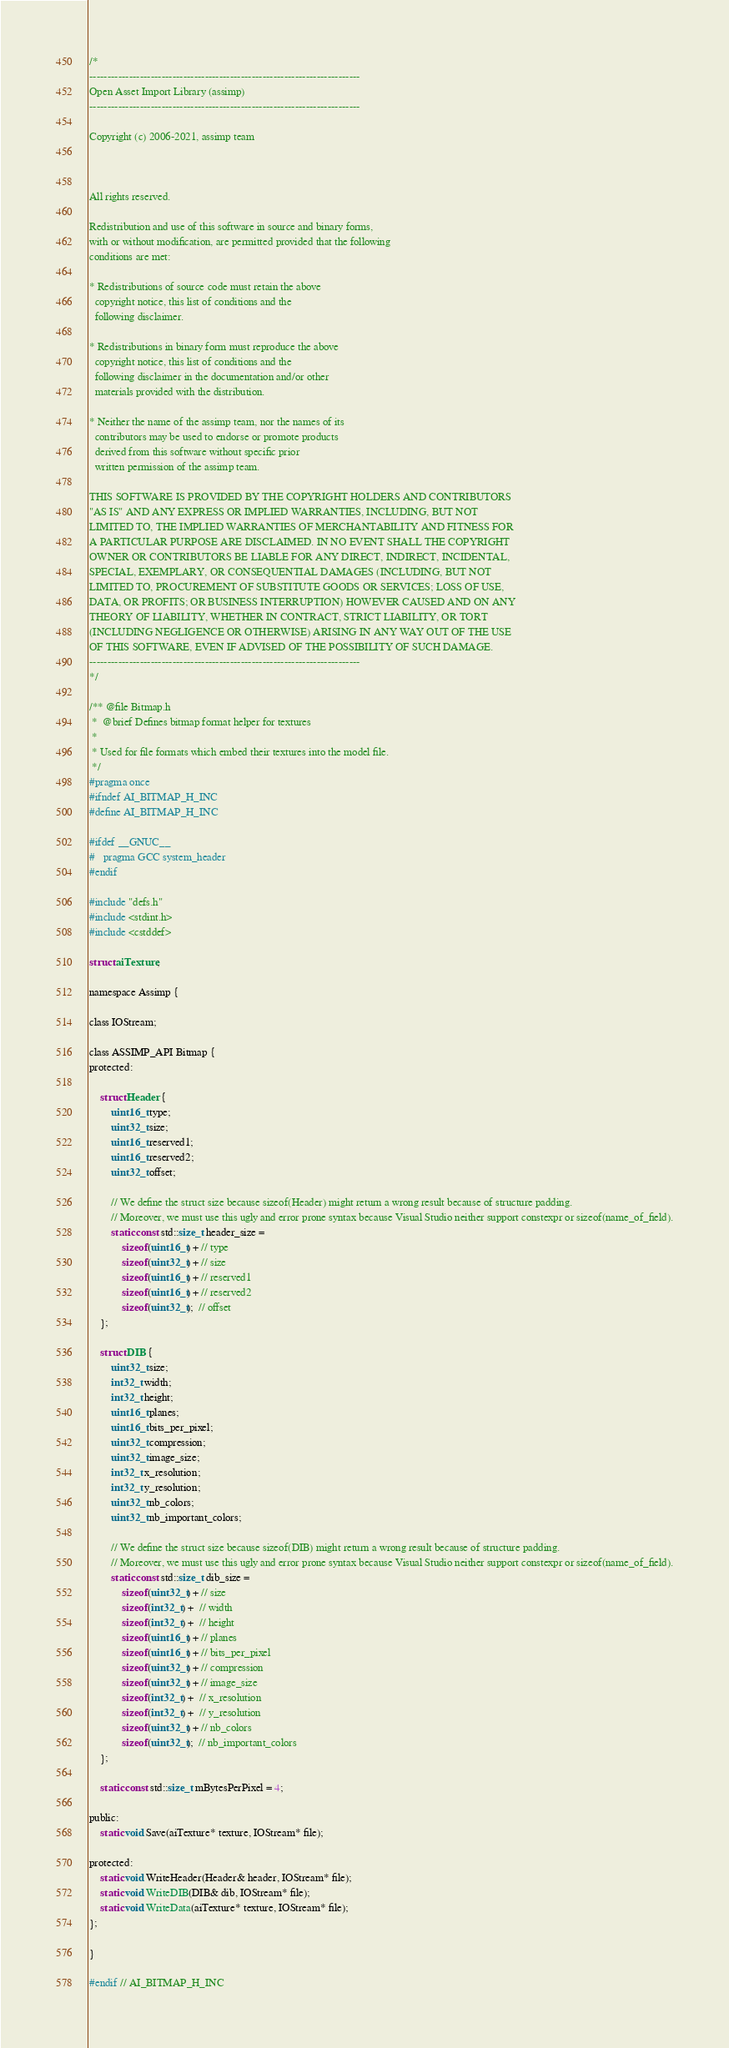Convert code to text. <code><loc_0><loc_0><loc_500><loc_500><_C_>/*
---------------------------------------------------------------------------
Open Asset Import Library (assimp)
---------------------------------------------------------------------------

Copyright (c) 2006-2021, assimp team



All rights reserved.

Redistribution and use of this software in source and binary forms,
with or without modification, are permitted provided that the following
conditions are met:

* Redistributions of source code must retain the above
  copyright notice, this list of conditions and the
  following disclaimer.

* Redistributions in binary form must reproduce the above
  copyright notice, this list of conditions and the
  following disclaimer in the documentation and/or other
  materials provided with the distribution.

* Neither the name of the assimp team, nor the names of its
  contributors may be used to endorse or promote products
  derived from this software without specific prior
  written permission of the assimp team.

THIS SOFTWARE IS PROVIDED BY THE COPYRIGHT HOLDERS AND CONTRIBUTORS
"AS IS" AND ANY EXPRESS OR IMPLIED WARRANTIES, INCLUDING, BUT NOT
LIMITED TO, THE IMPLIED WARRANTIES OF MERCHANTABILITY AND FITNESS FOR
A PARTICULAR PURPOSE ARE DISCLAIMED. IN NO EVENT SHALL THE COPYRIGHT
OWNER OR CONTRIBUTORS BE LIABLE FOR ANY DIRECT, INDIRECT, INCIDENTAL,
SPECIAL, EXEMPLARY, OR CONSEQUENTIAL DAMAGES (INCLUDING, BUT NOT
LIMITED TO, PROCUREMENT OF SUBSTITUTE GOODS OR SERVICES; LOSS OF USE,
DATA, OR PROFITS; OR BUSINESS INTERRUPTION) HOWEVER CAUSED AND ON ANY
THEORY OF LIABILITY, WHETHER IN CONTRACT, STRICT LIABILITY, OR TORT
(INCLUDING NEGLIGENCE OR OTHERWISE) ARISING IN ANY WAY OUT OF THE USE
OF THIS SOFTWARE, EVEN IF ADVISED OF THE POSSIBILITY OF SUCH DAMAGE.
---------------------------------------------------------------------------
*/

/** @file Bitmap.h
 *  @brief Defines bitmap format helper for textures
 *
 * Used for file formats which embed their textures into the model file.
 */
#pragma once
#ifndef AI_BITMAP_H_INC
#define AI_BITMAP_H_INC

#ifdef __GNUC__
#   pragma GCC system_header
#endif

#include "defs.h"
#include <stdint.h>
#include <cstddef>

struct aiTexture;

namespace Assimp {

class IOStream;

class ASSIMP_API Bitmap {
protected:

    struct Header {
        uint16_t type;
        uint32_t size;
        uint16_t reserved1;
        uint16_t reserved2;
        uint32_t offset;

        // We define the struct size because sizeof(Header) might return a wrong result because of structure padding.
        // Moreover, we must use this ugly and error prone syntax because Visual Studio neither support constexpr or sizeof(name_of_field).
        static const std::size_t header_size =
            sizeof(uint16_t) + // type
            sizeof(uint32_t) + // size
            sizeof(uint16_t) + // reserved1
            sizeof(uint16_t) + // reserved2
            sizeof(uint32_t);  // offset
    };

    struct DIB {
        uint32_t size;
        int32_t width;
        int32_t height;
        uint16_t planes;
        uint16_t bits_per_pixel;
        uint32_t compression;
        uint32_t image_size;
        int32_t x_resolution;
        int32_t y_resolution;
        uint32_t nb_colors;
        uint32_t nb_important_colors;

        // We define the struct size because sizeof(DIB) might return a wrong result because of structure padding.
        // Moreover, we must use this ugly and error prone syntax because Visual Studio neither support constexpr or sizeof(name_of_field).
        static const std::size_t dib_size =
            sizeof(uint32_t) + // size
            sizeof(int32_t) +  // width
            sizeof(int32_t) +  // height
            sizeof(uint16_t) + // planes
            sizeof(uint16_t) + // bits_per_pixel
            sizeof(uint32_t) + // compression
            sizeof(uint32_t) + // image_size
            sizeof(int32_t) +  // x_resolution
            sizeof(int32_t) +  // y_resolution
            sizeof(uint32_t) + // nb_colors
            sizeof(uint32_t);  // nb_important_colors
    };

    static const std::size_t mBytesPerPixel = 4;

public:
    static void Save(aiTexture* texture, IOStream* file);

protected:
    static void WriteHeader(Header& header, IOStream* file);
    static void WriteDIB(DIB& dib, IOStream* file);
    static void WriteData(aiTexture* texture, IOStream* file);
};

}

#endif // AI_BITMAP_H_INC
</code> 